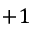Convert formula to latex. <formula><loc_0><loc_0><loc_500><loc_500>+ 1</formula> 